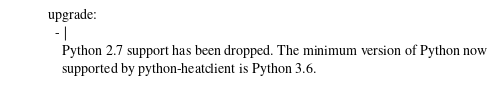<code> <loc_0><loc_0><loc_500><loc_500><_YAML_>upgrade:
  - |
    Python 2.7 support has been dropped. The minimum version of Python now
    supported by python-heatclient is Python 3.6.
</code> 